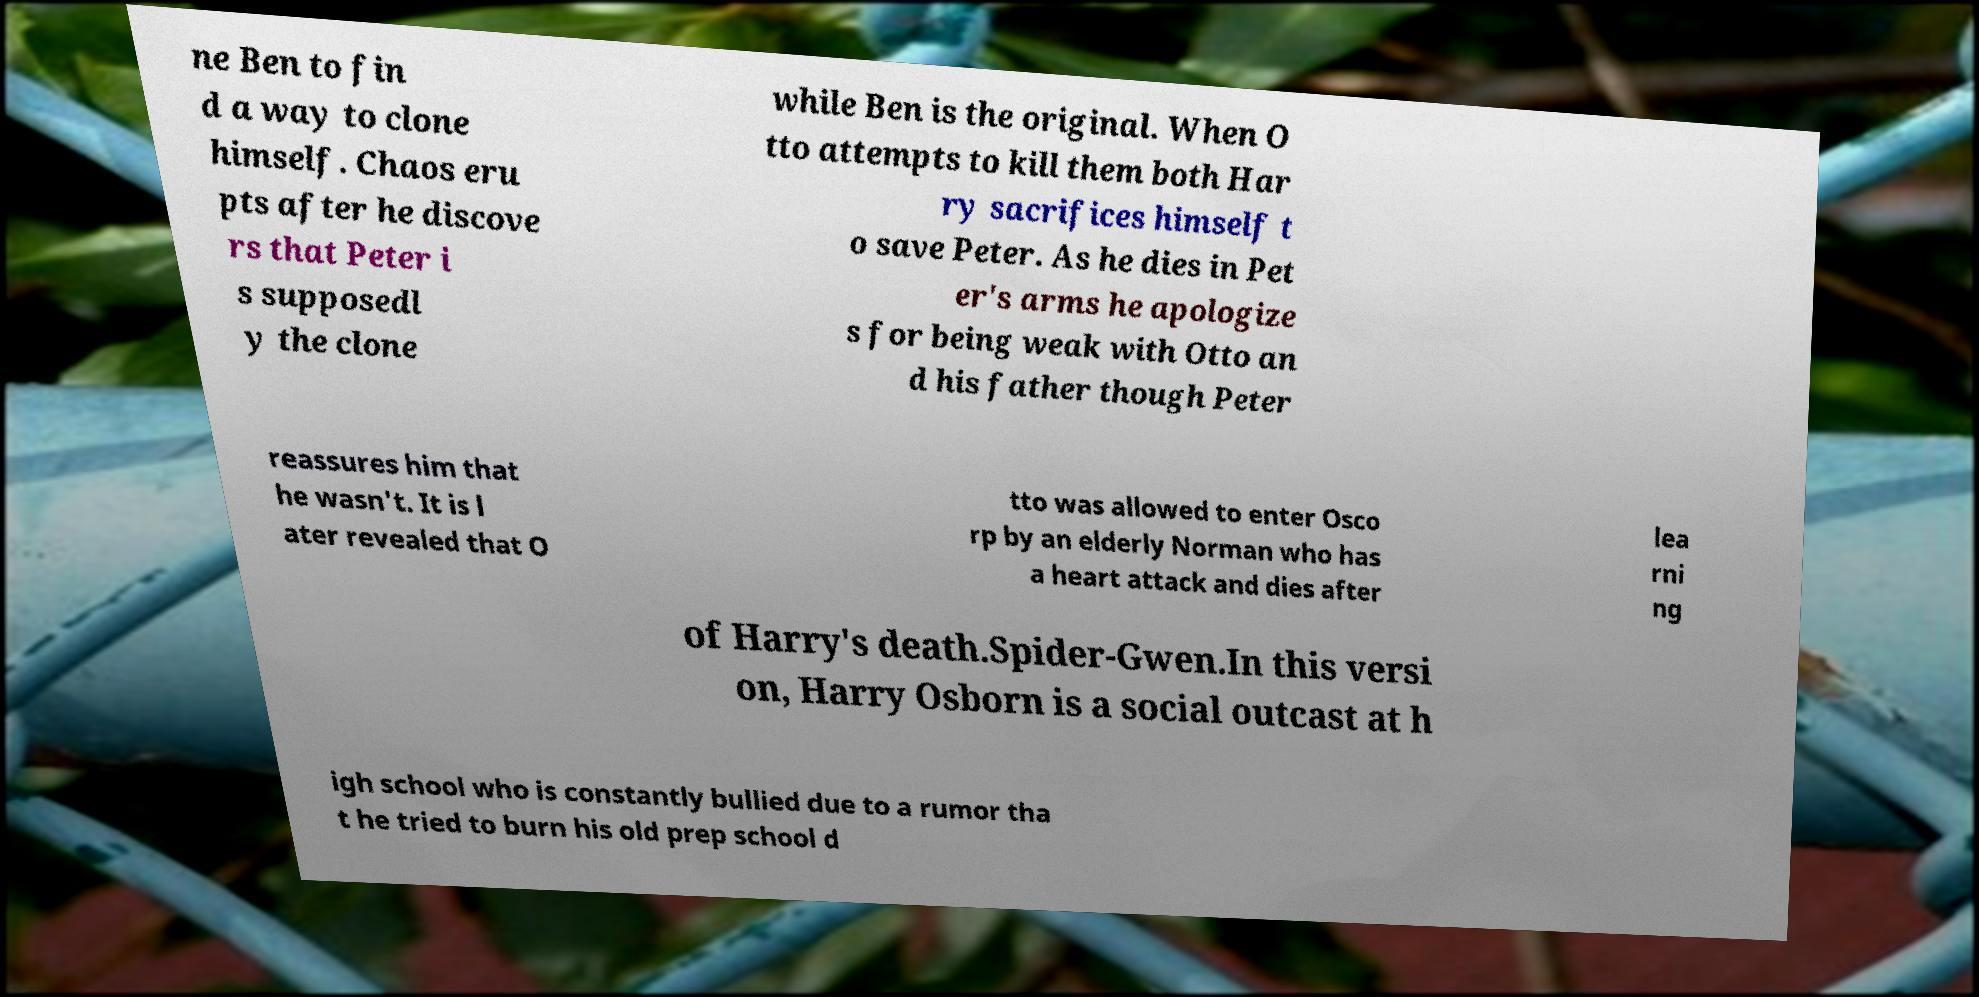For documentation purposes, I need the text within this image transcribed. Could you provide that? ne Ben to fin d a way to clone himself. Chaos eru pts after he discove rs that Peter i s supposedl y the clone while Ben is the original. When O tto attempts to kill them both Har ry sacrifices himself t o save Peter. As he dies in Pet er's arms he apologize s for being weak with Otto an d his father though Peter reassures him that he wasn't. It is l ater revealed that O tto was allowed to enter Osco rp by an elderly Norman who has a heart attack and dies after lea rni ng of Harry's death.Spider-Gwen.In this versi on, Harry Osborn is a social outcast at h igh school who is constantly bullied due to a rumor tha t he tried to burn his old prep school d 